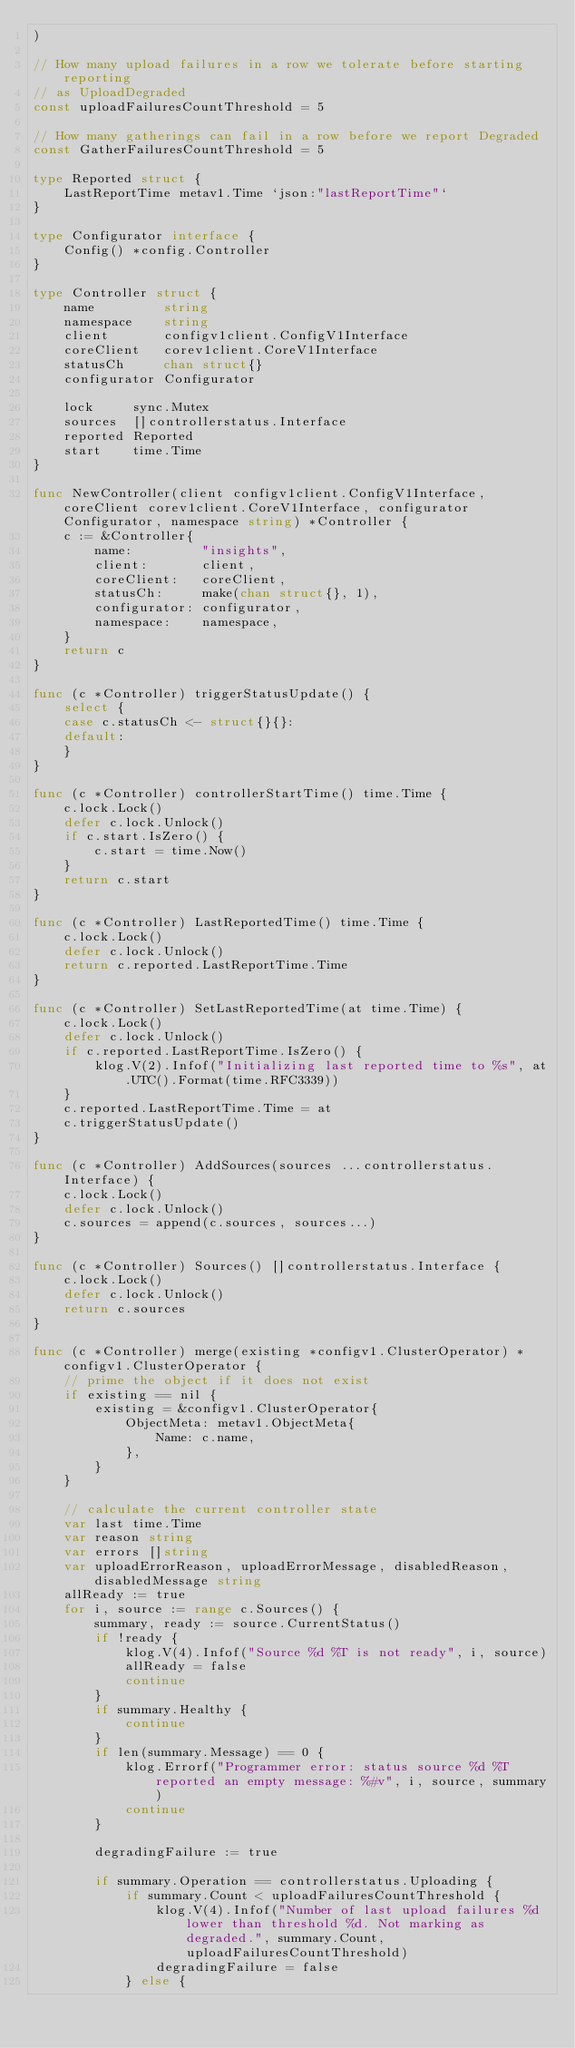Convert code to text. <code><loc_0><loc_0><loc_500><loc_500><_Go_>)

// How many upload failures in a row we tolerate before starting reporting
// as UploadDegraded
const uploadFailuresCountThreshold = 5

// How many gatherings can fail in a row before we report Degraded
const GatherFailuresCountThreshold = 5

type Reported struct {
	LastReportTime metav1.Time `json:"lastReportTime"`
}

type Configurator interface {
	Config() *config.Controller
}

type Controller struct {
	name         string
	namespace    string
	client       configv1client.ConfigV1Interface
	coreClient   corev1client.CoreV1Interface
	statusCh     chan struct{}
	configurator Configurator

	lock     sync.Mutex
	sources  []controllerstatus.Interface
	reported Reported
	start    time.Time
}

func NewController(client configv1client.ConfigV1Interface, coreClient corev1client.CoreV1Interface, configurator Configurator, namespace string) *Controller {
	c := &Controller{
		name:         "insights",
		client:       client,
		coreClient:   coreClient,
		statusCh:     make(chan struct{}, 1),
		configurator: configurator,
		namespace:    namespace,
	}
	return c
}

func (c *Controller) triggerStatusUpdate() {
	select {
	case c.statusCh <- struct{}{}:
	default:
	}
}

func (c *Controller) controllerStartTime() time.Time {
	c.lock.Lock()
	defer c.lock.Unlock()
	if c.start.IsZero() {
		c.start = time.Now()
	}
	return c.start
}

func (c *Controller) LastReportedTime() time.Time {
	c.lock.Lock()
	defer c.lock.Unlock()
	return c.reported.LastReportTime.Time
}

func (c *Controller) SetLastReportedTime(at time.Time) {
	c.lock.Lock()
	defer c.lock.Unlock()
	if c.reported.LastReportTime.IsZero() {
		klog.V(2).Infof("Initializing last reported time to %s", at.UTC().Format(time.RFC3339))
	}
	c.reported.LastReportTime.Time = at
	c.triggerStatusUpdate()
}

func (c *Controller) AddSources(sources ...controllerstatus.Interface) {
	c.lock.Lock()
	defer c.lock.Unlock()
	c.sources = append(c.sources, sources...)
}

func (c *Controller) Sources() []controllerstatus.Interface {
	c.lock.Lock()
	defer c.lock.Unlock()
	return c.sources
}

func (c *Controller) merge(existing *configv1.ClusterOperator) *configv1.ClusterOperator {
	// prime the object if it does not exist
	if existing == nil {
		existing = &configv1.ClusterOperator{
			ObjectMeta: metav1.ObjectMeta{
				Name: c.name,
			},
		}
	}

	// calculate the current controller state
	var last time.Time
	var reason string
	var errors []string
	var uploadErrorReason, uploadErrorMessage, disabledReason, disabledMessage string
	allReady := true
	for i, source := range c.Sources() {
		summary, ready := source.CurrentStatus()
		if !ready {
			klog.V(4).Infof("Source %d %T is not ready", i, source)
			allReady = false
			continue
		}
		if summary.Healthy {
			continue
		}
		if len(summary.Message) == 0 {
			klog.Errorf("Programmer error: status source %d %T reported an empty message: %#v", i, source, summary)
			continue
		}

		degradingFailure := true

		if summary.Operation == controllerstatus.Uploading {
			if summary.Count < uploadFailuresCountThreshold {
				klog.V(4).Infof("Number of last upload failures %d lower than threshold %d. Not marking as degraded.", summary.Count, uploadFailuresCountThreshold)
				degradingFailure = false
			} else {</code> 